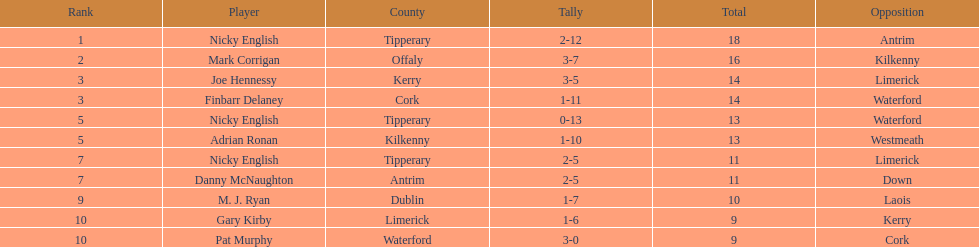What was the mean total for both nicky english and mark corrigan? 17. 